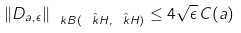Convert formula to latex. <formula><loc_0><loc_0><loc_500><loc_500>\| D _ { a , \epsilon } \| _ { \ k B ( \hat { \ k H } , \hat { \ k H } ) } \leq 4 \sqrt { \epsilon } \, C ( a )</formula> 